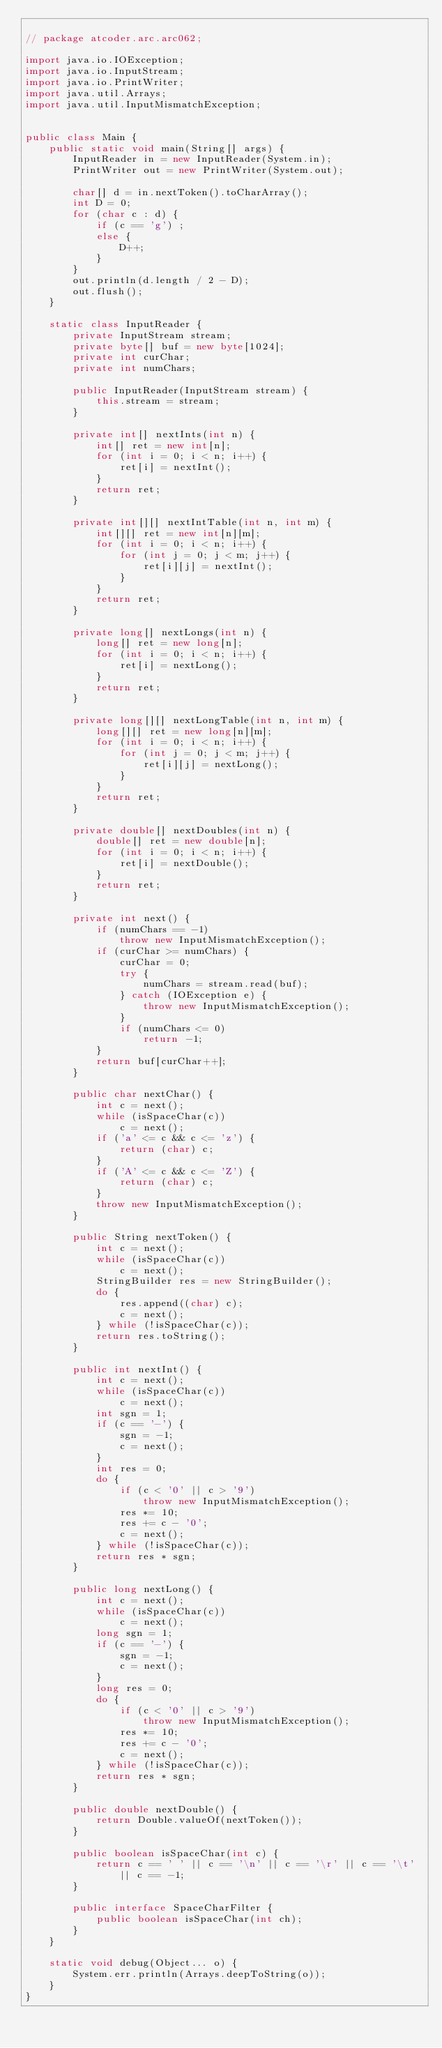Convert code to text. <code><loc_0><loc_0><loc_500><loc_500><_Java_>
// package atcoder.arc.arc062;

import java.io.IOException;
import java.io.InputStream;
import java.io.PrintWriter;
import java.util.Arrays;
import java.util.InputMismatchException;


public class Main {
	public static void main(String[] args) {
		InputReader in = new InputReader(System.in);
		PrintWriter out = new PrintWriter(System.out);

		char[] d = in.nextToken().toCharArray();
		int D = 0;
		for (char c : d) {
			if (c == 'g') ;
			else {
				D++;
			}
		}
		out.println(d.length / 2 - D);
		out.flush();
	}

	static class InputReader {
		private InputStream stream;
		private byte[] buf = new byte[1024];
		private int curChar;
		private int numChars;

		public InputReader(InputStream stream) {
			this.stream = stream;
		}

		private int[] nextInts(int n) {
			int[] ret = new int[n];
			for (int i = 0; i < n; i++) {
				ret[i] = nextInt();
			}
			return ret;
		}

		private int[][] nextIntTable(int n, int m) {
			int[][] ret = new int[n][m];
			for (int i = 0; i < n; i++) {
				for (int j = 0; j < m; j++) {
					ret[i][j] = nextInt();
				}
			}
			return ret;
		}

		private long[] nextLongs(int n) {
			long[] ret = new long[n];
			for (int i = 0; i < n; i++) {
				ret[i] = nextLong();
			}
			return ret;
		}

		private long[][] nextLongTable(int n, int m) {
			long[][] ret = new long[n][m];
			for (int i = 0; i < n; i++) {
				for (int j = 0; j < m; j++) {
					ret[i][j] = nextLong();
				}
			}
			return ret;
		}

		private double[] nextDoubles(int n) {
			double[] ret = new double[n];
			for (int i = 0; i < n; i++) {
				ret[i] = nextDouble();
			}
			return ret;
		}

		private int next() {
			if (numChars == -1)
				throw new InputMismatchException();
			if (curChar >= numChars) {
				curChar = 0;
				try {
					numChars = stream.read(buf);
				} catch (IOException e) {
					throw new InputMismatchException();
				}
				if (numChars <= 0)
					return -1;
			}
			return buf[curChar++];
		}

		public char nextChar() {
			int c = next();
			while (isSpaceChar(c))
				c = next();
			if ('a' <= c && c <= 'z') {
				return (char) c;
			}
			if ('A' <= c && c <= 'Z') {
				return (char) c;
			}
			throw new InputMismatchException();
		}

		public String nextToken() {
			int c = next();
			while (isSpaceChar(c))
				c = next();
			StringBuilder res = new StringBuilder();
			do {
				res.append((char) c);
				c = next();
			} while (!isSpaceChar(c));
			return res.toString();
		}

		public int nextInt() {
			int c = next();
			while (isSpaceChar(c))
				c = next();
			int sgn = 1;
			if (c == '-') {
				sgn = -1;
				c = next();
			}
			int res = 0;
			do {
				if (c < '0' || c > '9')
					throw new InputMismatchException();
				res *= 10;
				res += c - '0';
				c = next();
			} while (!isSpaceChar(c));
			return res * sgn;
		}

		public long nextLong() {
			int c = next();
			while (isSpaceChar(c))
				c = next();
			long sgn = 1;
			if (c == '-') {
				sgn = -1;
				c = next();
			}
			long res = 0;
			do {
				if (c < '0' || c > '9')
					throw new InputMismatchException();
				res *= 10;
				res += c - '0';
				c = next();
			} while (!isSpaceChar(c));
			return res * sgn;
		}

		public double nextDouble() {
			return Double.valueOf(nextToken());
		}

		public boolean isSpaceChar(int c) {
			return c == ' ' || c == '\n' || c == '\r' || c == '\t' || c == -1;
		}

		public interface SpaceCharFilter {
			public boolean isSpaceChar(int ch);
		}
	}

	static void debug(Object... o) {
		System.err.println(Arrays.deepToString(o));
	}
}
</code> 